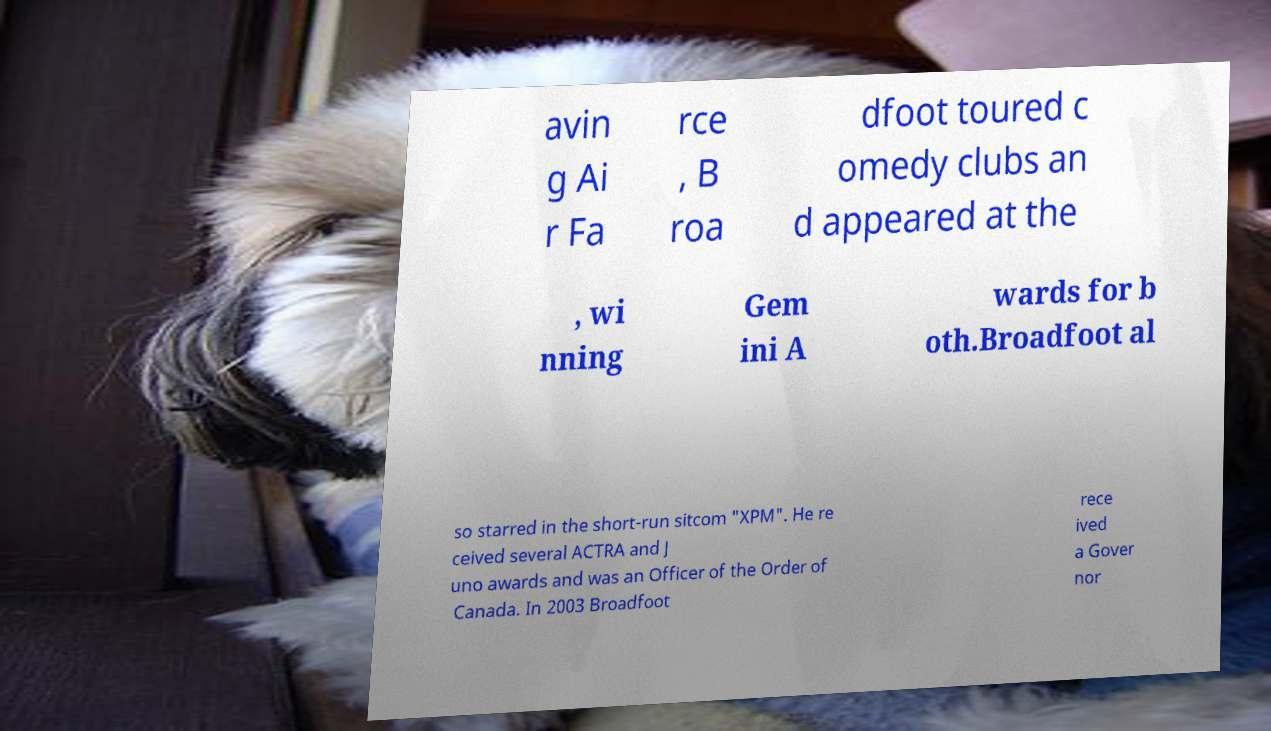What messages or text are displayed in this image? I need them in a readable, typed format. avin g Ai r Fa rce , B roa dfoot toured c omedy clubs an d appeared at the , wi nning Gem ini A wards for b oth.Broadfoot al so starred in the short-run sitcom "XPM". He re ceived several ACTRA and J uno awards and was an Officer of the Order of Canada. In 2003 Broadfoot rece ived a Gover nor 